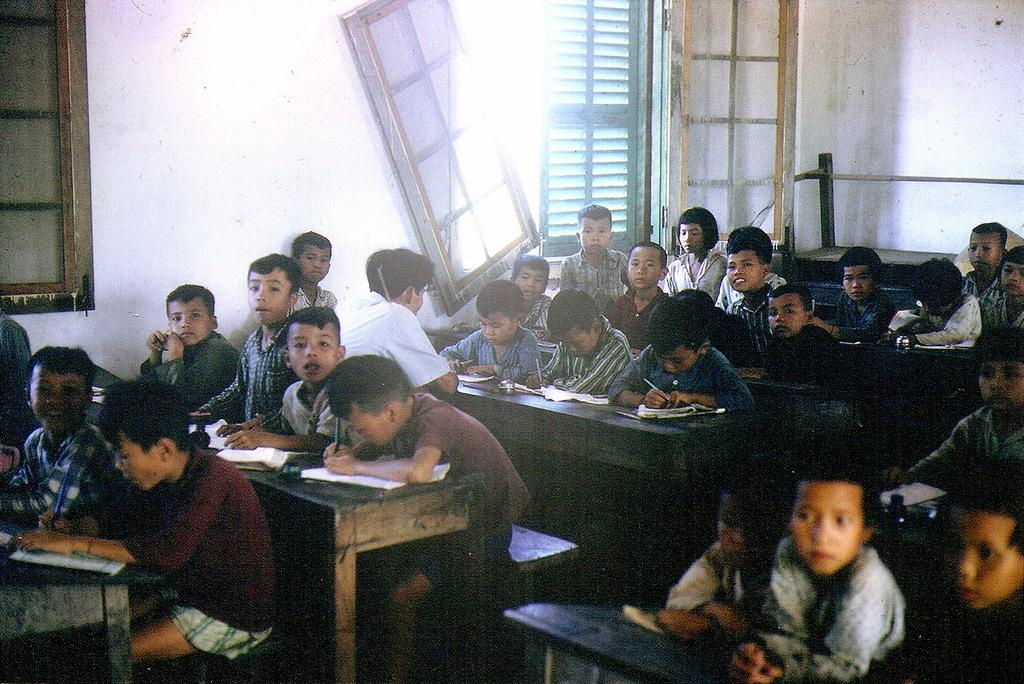What is the main subject of the image? The main subject of the image is a group of children. What are the children doing in the image? The children are sitting on benches and writing in books. What can be seen in the background of the image? There is a wall and windows in the background of the image. What type of lipstick is the achiever wearing in the image? There is no achiever or lipstick present in the image; it features a group of children sitting on benches and writing in books. What kind of stone is used to build the wall in the image? The type of stone used to build the wall is not visible or mentioned in the image. 